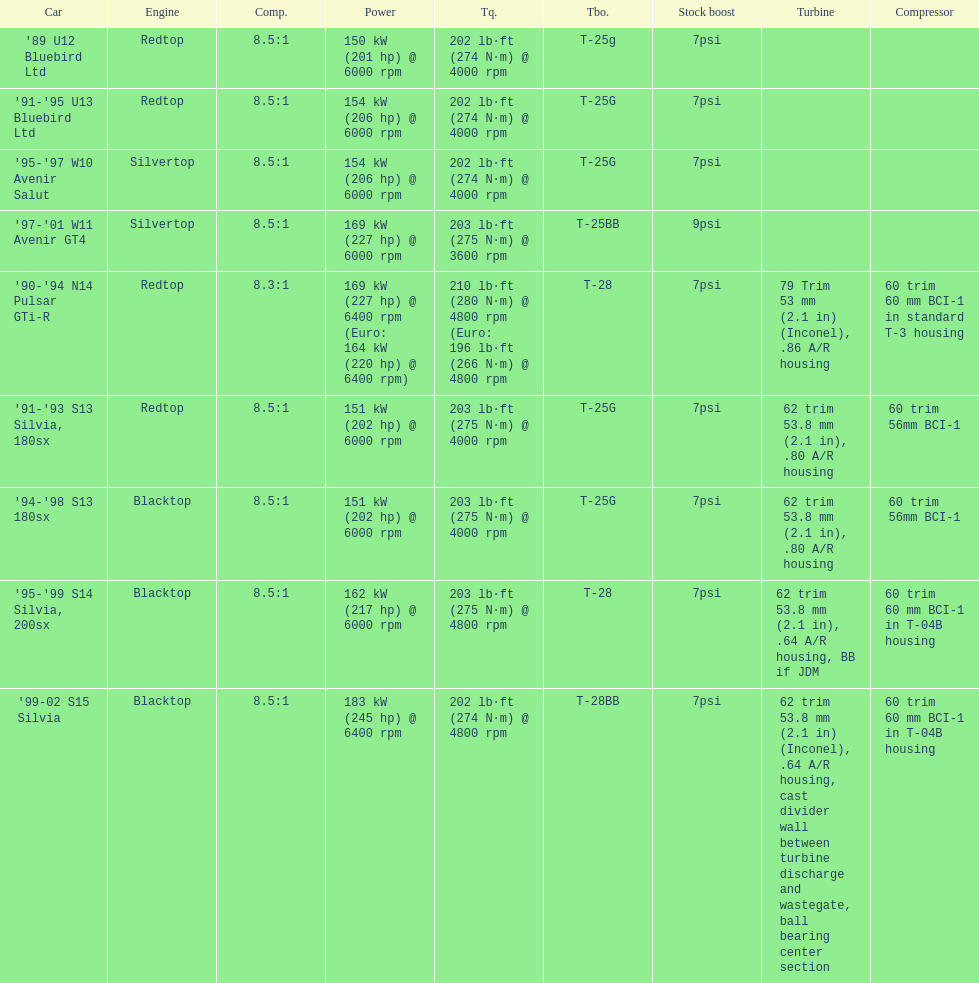Which engines are the same as the first entry ('89 u12 bluebird ltd)? '91-'95 U13 Bluebird Ltd, '90-'94 N14 Pulsar GTi-R, '91-'93 S13 Silvia, 180sx. 